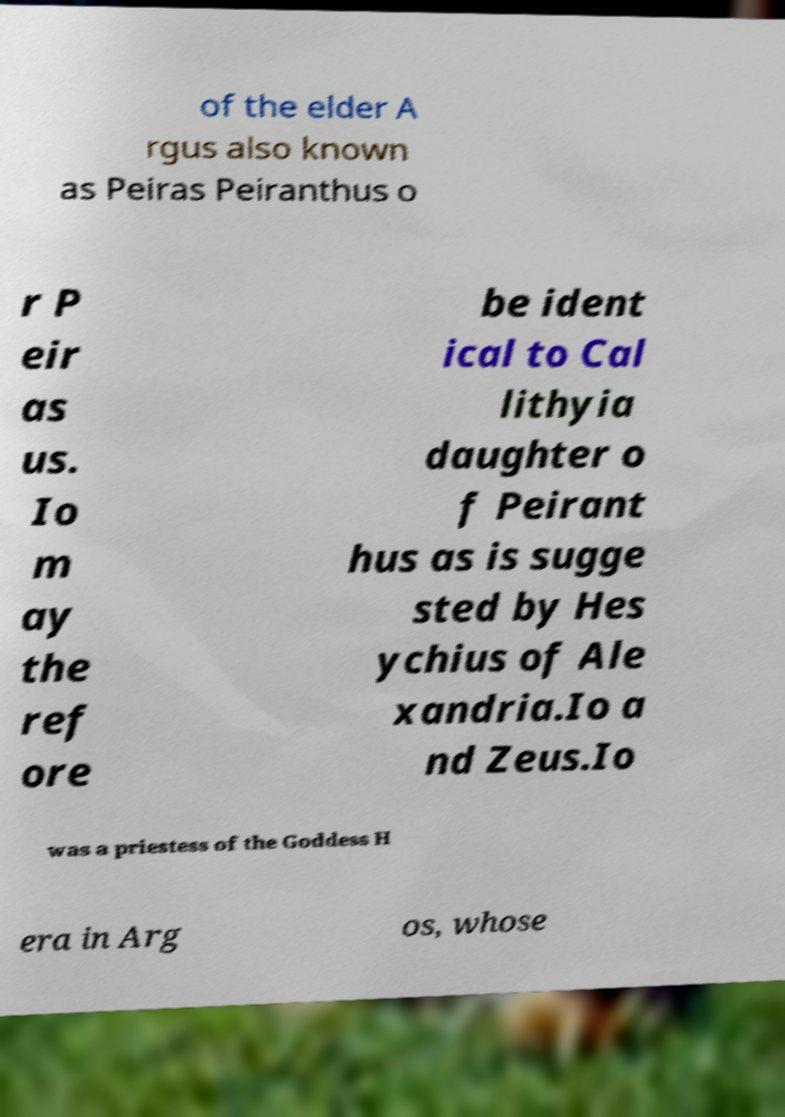Can you tell more about the mythological story of Io and Argus as mentioned in the text? Io, in Greek mythology, was a priestess of Hera who was transformed into a white heifer. Argus, also known as Argus Panoptes, was a giant with many eyes tasked by Hera to watch Io. This myth is rich with themes of jealousy, transformation, and escape, often interpreted as a tale of vigilance and change. 